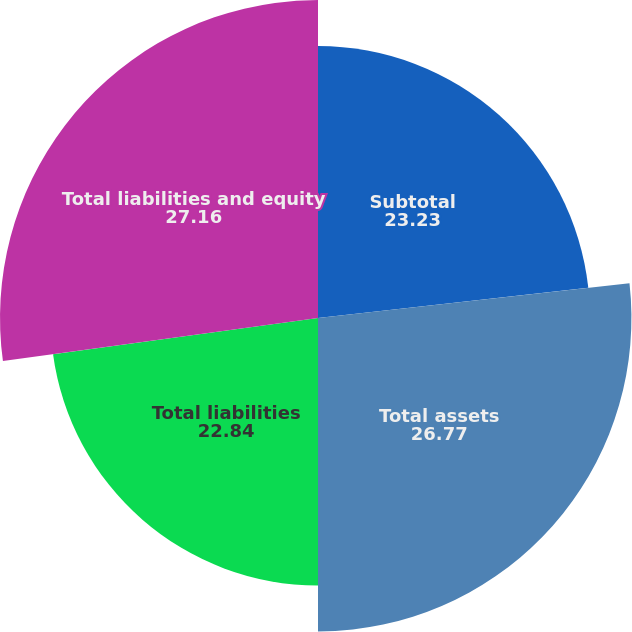<chart> <loc_0><loc_0><loc_500><loc_500><pie_chart><fcel>Subtotal<fcel>Total assets<fcel>Total liabilities<fcel>Total liabilities and equity<nl><fcel>23.23%<fcel>26.77%<fcel>22.84%<fcel>27.16%<nl></chart> 